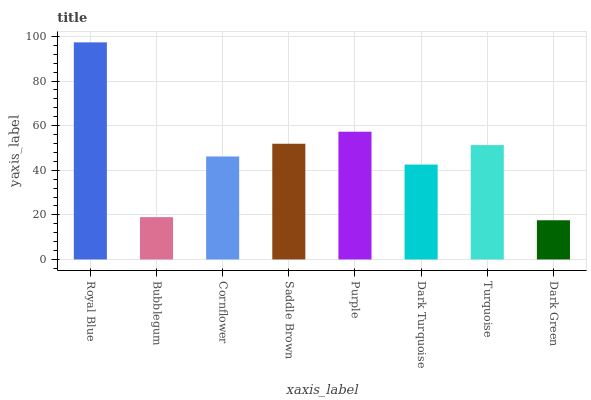Is Dark Green the minimum?
Answer yes or no. Yes. Is Royal Blue the maximum?
Answer yes or no. Yes. Is Bubblegum the minimum?
Answer yes or no. No. Is Bubblegum the maximum?
Answer yes or no. No. Is Royal Blue greater than Bubblegum?
Answer yes or no. Yes. Is Bubblegum less than Royal Blue?
Answer yes or no. Yes. Is Bubblegum greater than Royal Blue?
Answer yes or no. No. Is Royal Blue less than Bubblegum?
Answer yes or no. No. Is Turquoise the high median?
Answer yes or no. Yes. Is Cornflower the low median?
Answer yes or no. Yes. Is Royal Blue the high median?
Answer yes or no. No. Is Royal Blue the low median?
Answer yes or no. No. 